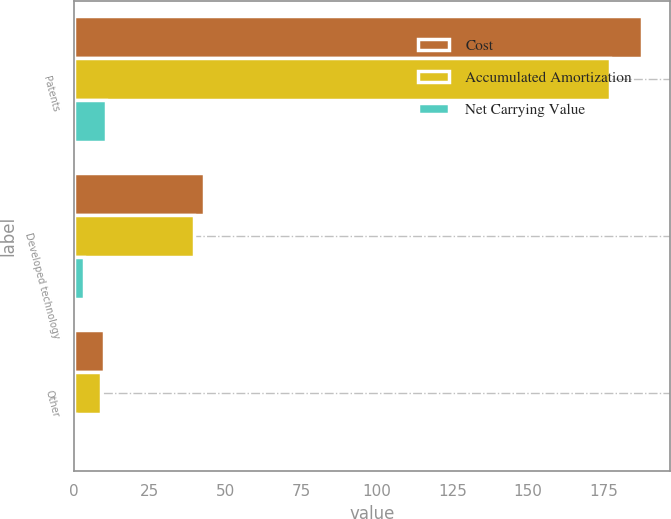<chart> <loc_0><loc_0><loc_500><loc_500><stacked_bar_chart><ecel><fcel>Patents<fcel>Developed technology<fcel>Other<nl><fcel>Cost<fcel>187.6<fcel>43<fcel>9.8<nl><fcel>Accumulated Amortization<fcel>177<fcel>39.6<fcel>9<nl><fcel>Net Carrying Value<fcel>10.6<fcel>3.4<fcel>0.8<nl></chart> 